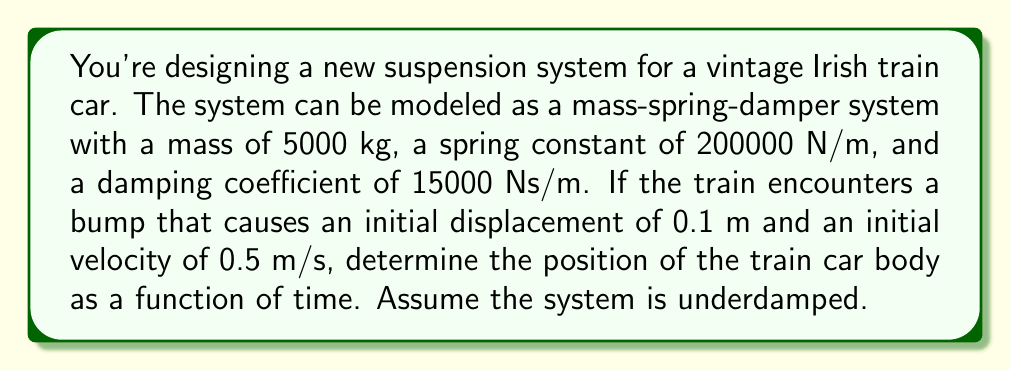Solve this math problem. To solve this problem, we need to use the general solution for an underdamped second-order differential equation. The equation of motion for a mass-spring-damper system is:

$$m\frac{d^2x}{dt^2} + c\frac{dx}{dt} + kx = 0$$

Where:
$m$ = mass (5000 kg)
$c$ = damping coefficient (15000 Ns/m)
$k$ = spring constant (200000 N/m)

Step 1: Calculate the natural frequency $\omega_n$:
$$\omega_n = \sqrt{\frac{k}{m}} = \sqrt{\frac{200000}{5000}} = 6.32 \text{ rad/s}$$

Step 2: Calculate the damping ratio $\zeta$:
$$\zeta = \frac{c}{2m\omega_n} = \frac{15000}{2(5000)(6.32)} = 0.237$$

Since $0 < \zeta < 1$, the system is indeed underdamped.

Step 3: Calculate the damped natural frequency $\omega_d$:
$$\omega_d = \omega_n\sqrt{1-\zeta^2} = 6.32\sqrt{1-0.237^2} = 6.15 \text{ rad/s}$$

Step 4: The general solution for an underdamped system is:
$$x(t) = e^{-\zeta\omega_n t}(A\cos(\omega_d t) + B\sin(\omega_d t))$$

Where $A$ and $B$ are constants determined by initial conditions.

Step 5: Use initial conditions to find $A$ and $B$:
$x(0) = 0.1 \text{ m}$, so $A = 0.1$

$\frac{dx}{dt}(0) = 0.5 \text{ m/s}$, so $B = \frac{0.5 + 0.1\zeta\omega_n}{\omega_d} = 0.0986$

Step 6: Substitute all values into the general solution:
$$x(t) = e^{-1.5t}(0.1\cos(6.15t) + 0.0986\sin(6.15t))$$

This equation represents the position of the train car body as a function of time.
Answer: $$x(t) = e^{-1.5t}(0.1\cos(6.15t) + 0.0986\sin(6.15t))$$ 